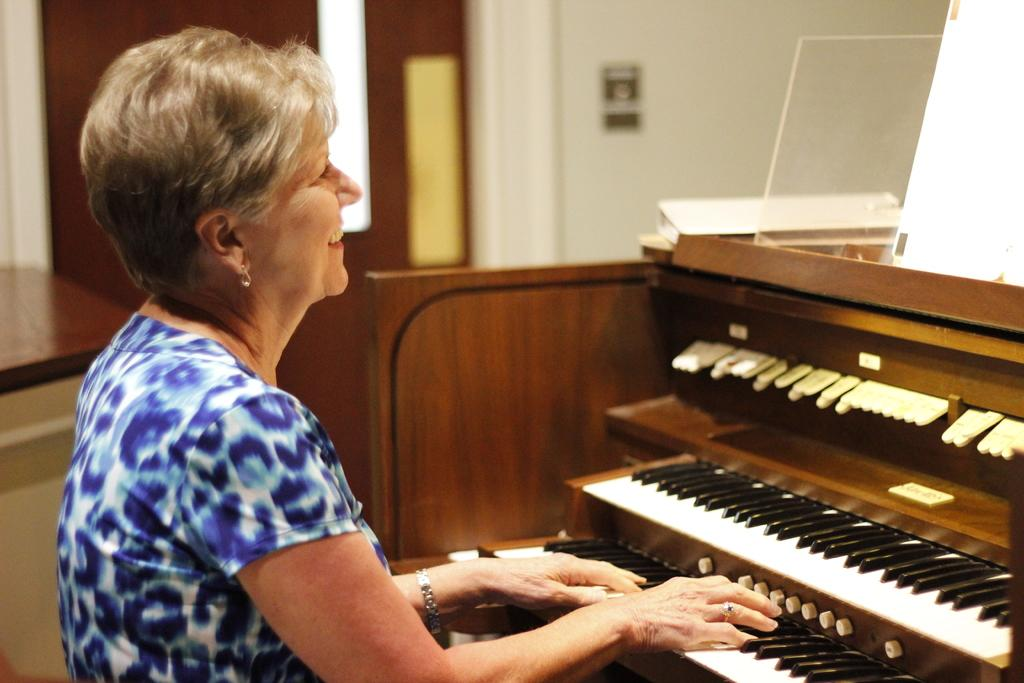Who is the main subject in the image? There is a lady in the image. What is the lady doing in the image? The lady is playing a piano. Is there any additional material related to the lady's activity? Yes, the lady is looking at a script, which is placed on top of the piano. What can be seen in the background of the image? There is a brown door in the background of the image. How does the lady use her breath to play the piano in the image? The lady does not use her breath to play the piano in the image; she uses her hands to press the keys. 